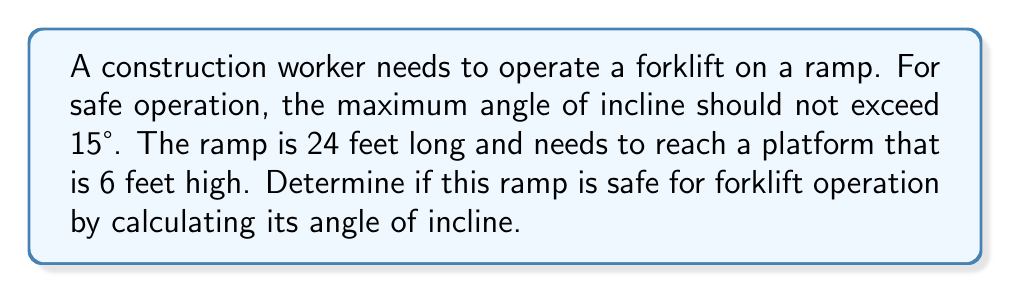Can you answer this question? To solve this problem, we need to use trigonometry:

1. Visualize the ramp as a right triangle:
   - The ramp length (24 feet) is the hypotenuse
   - The height (6 feet) is the opposite side
   - The angle of incline is what we need to find

2. We can use the sine function to find the angle:

   $$\sin(\theta) = \frac{\text{opposite}}{\text{hypotenuse}} = \frac{\text{height}}{\text{ramp length}}$$

3. Substitute the known values:

   $$\sin(\theta) = \frac{6}{24} = \frac{1}{4} = 0.25$$

4. To find the angle, we need to use the inverse sine (arcsin) function:

   $$\theta = \arcsin(0.25)$$

5. Using a calculator or trigonometric tables:

   $$\theta \approx 14.48^\circ$$

6. Compare this to the maximum safe angle of 15°:
   14.48° < 15°

Therefore, the ramp is safe for forklift operation as its angle of incline is less than the maximum safe angle.
Answer: $14.48^\circ$; safe for operation 